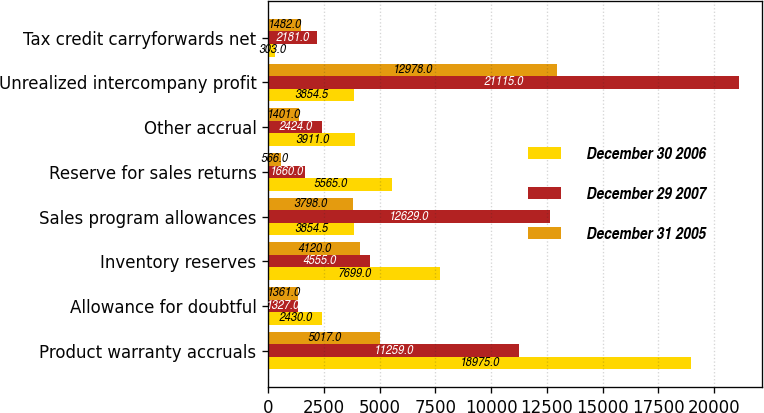Convert chart. <chart><loc_0><loc_0><loc_500><loc_500><stacked_bar_chart><ecel><fcel>Product warranty accruals<fcel>Allowance for doubtful<fcel>Inventory reserves<fcel>Sales program allowances<fcel>Reserve for sales returns<fcel>Other accrual<fcel>Unrealized intercompany profit<fcel>Tax credit carryforwards net<nl><fcel>December 30 2006<fcel>18975<fcel>2430<fcel>7699<fcel>3854.5<fcel>5565<fcel>3911<fcel>3854.5<fcel>303<nl><fcel>December 29 2007<fcel>11259<fcel>1327<fcel>4555<fcel>12629<fcel>1660<fcel>2424<fcel>21115<fcel>2181<nl><fcel>December 31 2005<fcel>5017<fcel>1361<fcel>4120<fcel>3798<fcel>566<fcel>1401<fcel>12978<fcel>1482<nl></chart> 